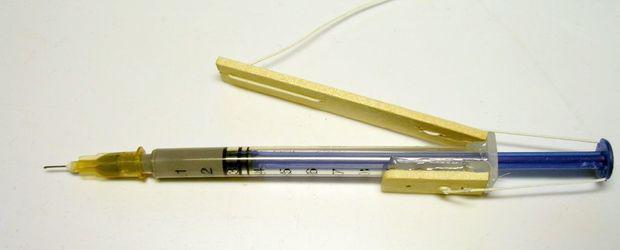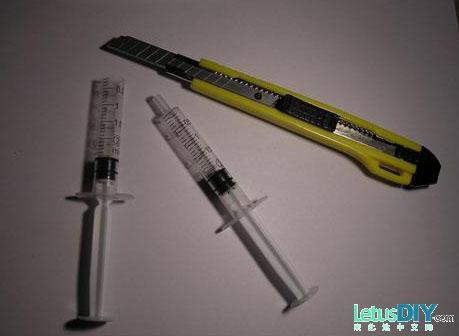The first image is the image on the left, the second image is the image on the right. Given the left and right images, does the statement "There is a white razor knife in the image on the right." hold true? Answer yes or no. Yes. 